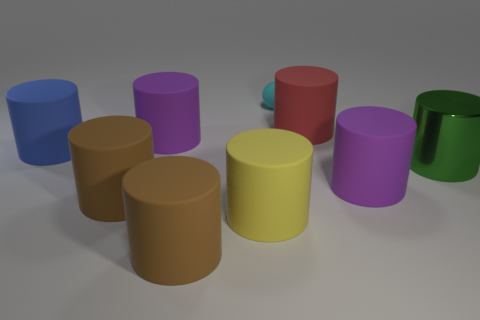What number of other objects are the same color as the metal cylinder?
Provide a succinct answer. 0. Are there more blue cylinders on the left side of the green metal cylinder than yellow rubber cylinders behind the blue object?
Keep it short and to the point. Yes. Is there any other thing that has the same size as the cyan matte thing?
Give a very brief answer. No. How many cylinders are either tiny matte things or large purple things?
Offer a terse response. 2. How many objects are either purple objects that are in front of the blue cylinder or purple spheres?
Offer a very short reply. 1. There is a big purple matte thing that is in front of the purple object that is to the left of the big purple thing that is in front of the metal cylinder; what shape is it?
Keep it short and to the point. Cylinder. What number of large purple matte things are the same shape as the red matte object?
Give a very brief answer. 2. Do the big yellow object and the large green cylinder have the same material?
Give a very brief answer. No. There is a big matte thing behind the purple matte object behind the large metallic object; what number of small cyan spheres are on the left side of it?
Your answer should be very brief. 1. Is there a large red cylinder that has the same material as the blue thing?
Your answer should be very brief. Yes. 